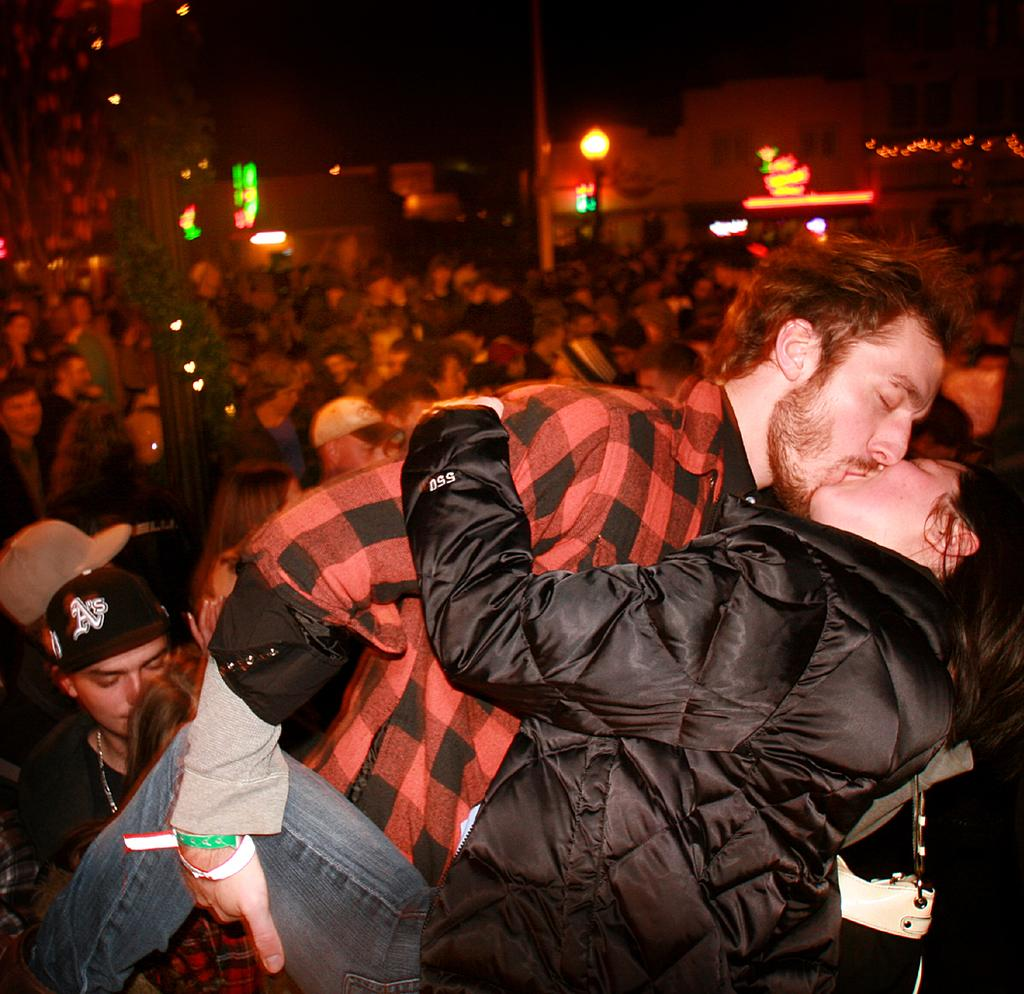How many people are in the image? There are people in the image, specifically two people who are kissing. What type of structures can be seen in the image? There are houses in the image. What objects in the image emit light? There are lights in the image. What type of plant is growing around a pole in the image? There is a creeper around a pole in the image. How would you describe the lighting conditions in the image? The background of the image is dark. What type of steam is visible coming from the houses in the image? There is no steam visible in the image; it only features people, houses, lights, a creeper, and a dark background. What season is depicted in the image? The image does not depict a specific season, as there are no seasonal cues present. 